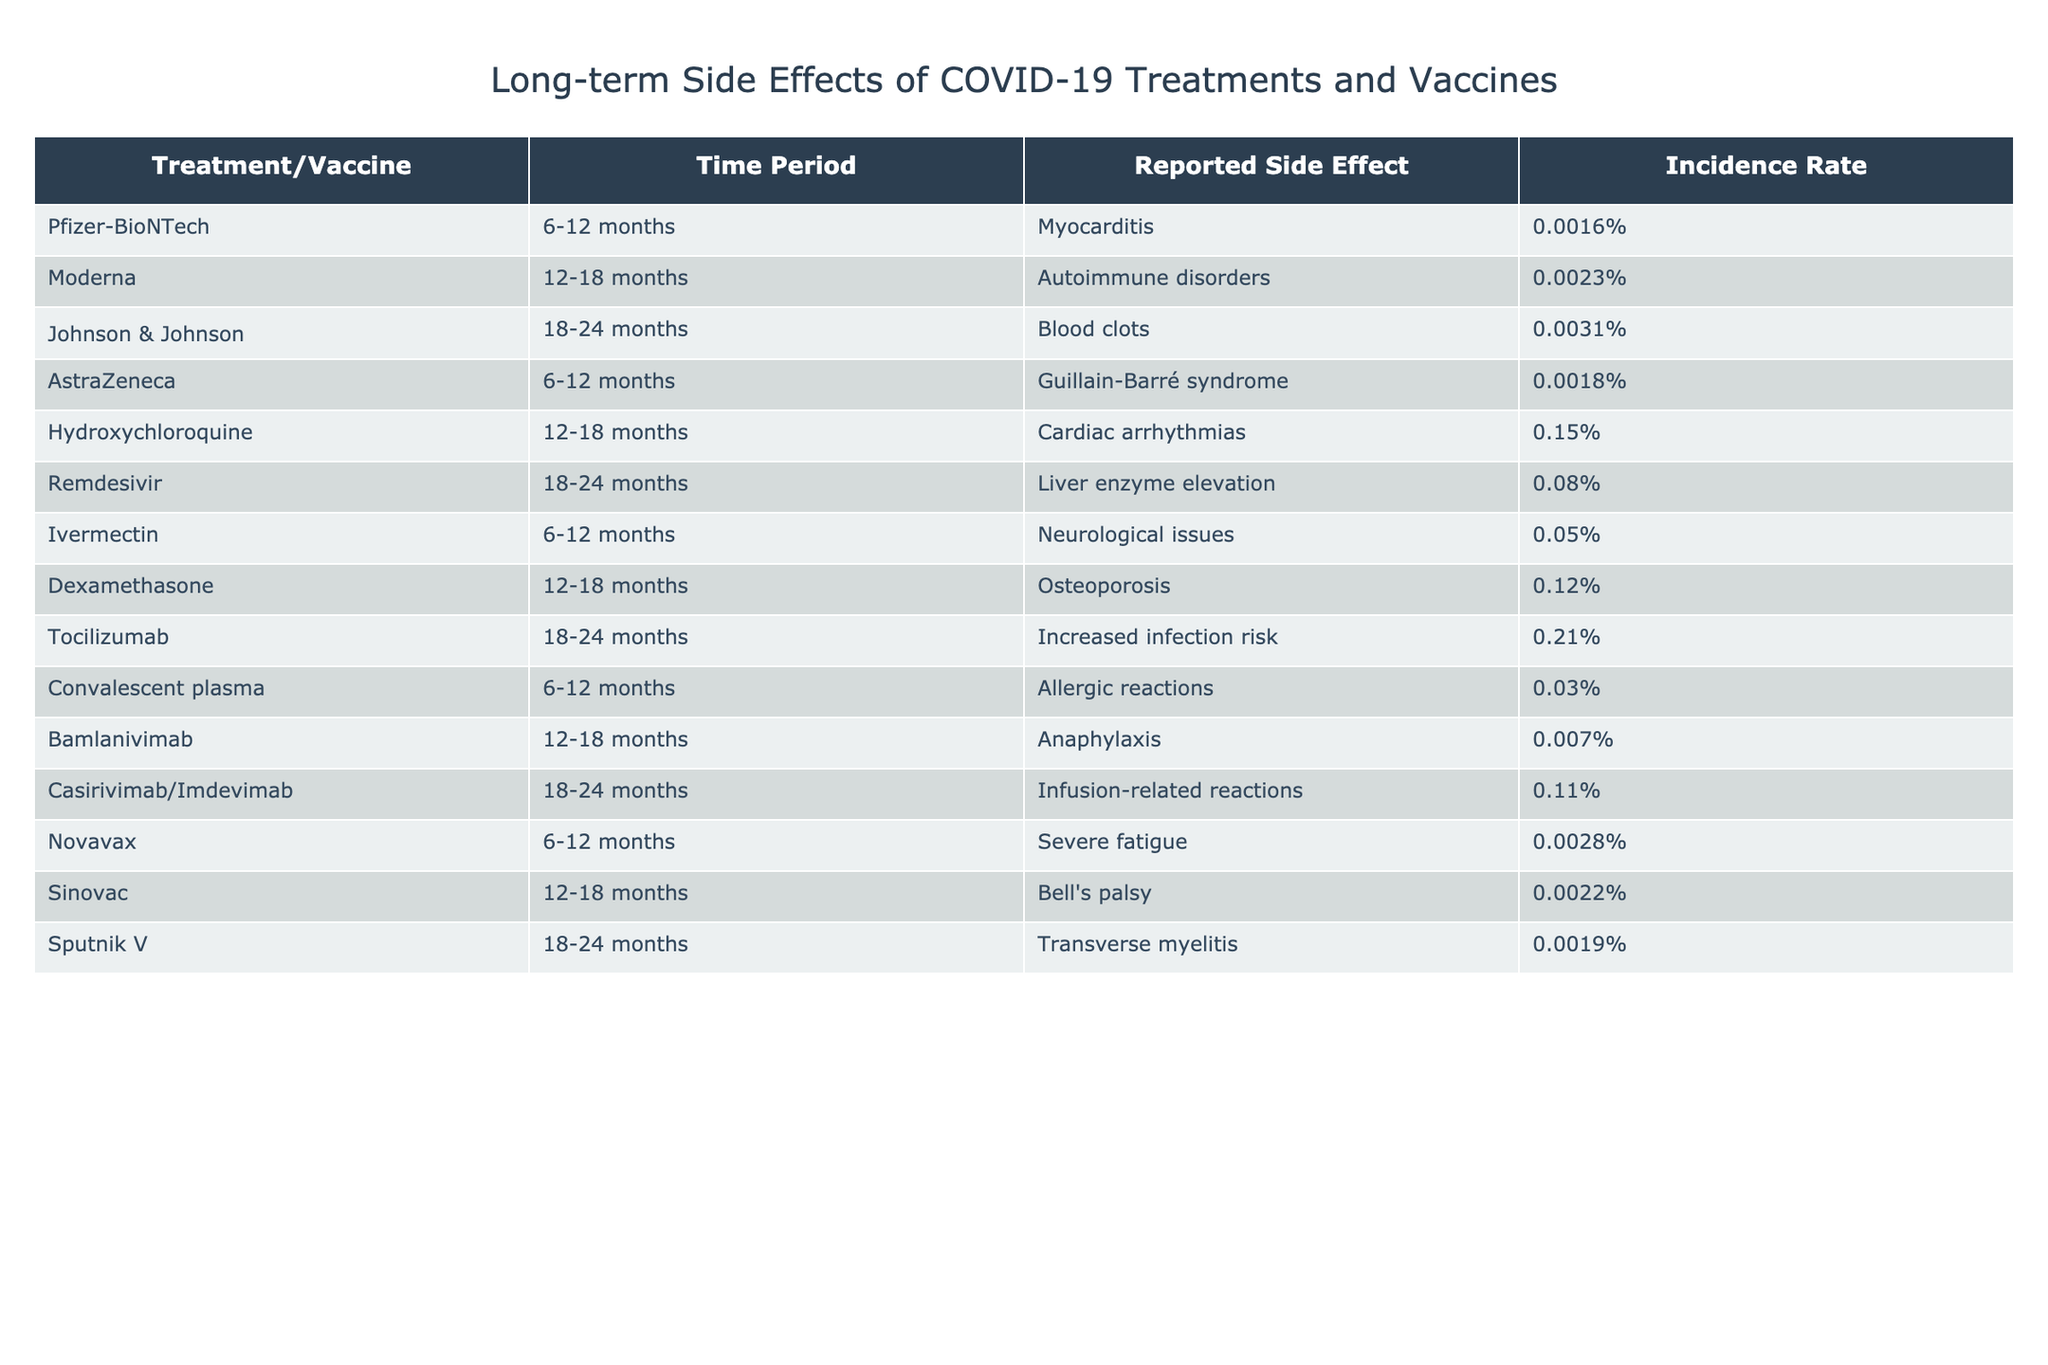What is the incidence rate of myocarditis after the Pfizer-BioNTech vaccine? The table shows that myocarditis is reported with an incidence rate of 0.0016% after the Pfizer-BioNTech vaccine.
Answer: 0.0016% Which treatment has the highest incidence rate for long-term side effects? In the table, hydroxychloroquine has the highest incidence rate for long-term side effects at 0.15%.
Answer: Hydroxychloroquine Is there a reported incidence of blood clots for the Johnson & Johnson vaccine? Yes, according to the table, blood clots are reported with an incidence rate of 0.0031% after the Johnson & Johnson vaccine.
Answer: Yes What is the average incidence rate of the reported side effects for all treatments and vaccines listed? By summing all the incidence rates: 0.0016 + 0.0023 + 0.0031 + 0.0018 + 0.15 + 0.08 + 0.05 + 0.12 + 0.21 + 0.03 + 0.007 + 0.11 + 0.0028 + 0.0022 + 0.0019 = 0.4, and there are 15 treatments, so, the average is 0.4/15 = 0.02667%.
Answer: 0.02667% Which side effect is associated with the AstraZeneca vaccine, and what is its incidence rate? The table states that the AstraZeneca vaccine is associated with Guillain-Barré syndrome, which has an incidence rate of 0.0018%.
Answer: Guillain-Barré syndrome, 0.0018% How many treatments or vaccines report an incidence rate higher than 0.1%? Looking through the table, the treatments that report an incidence higher than 0.1% are hydroxychloroquine (0.15%), remdesivir (0.08%), tocilizumab (0.21%), and dexamethasone (0.12%). Thus, 4 treatments have an incidence rate above 0.1%.
Answer: 4 What is the difference in incidence rates between the side effects of the Moderna vaccine and the Hydroxychloroquine treatment? The incidence rate for autoimmune disorders after the Moderna vaccine is 0.0023%, and for cardiac arrhythmias from hydroxychloroquine, it is 0.15%. The difference is calculated as 0.15% - 0.0023% = 0.1477%.
Answer: 0.1477% Does the incidence of severe fatigue from the Novavax vaccine exceed 0.002%? The table lists severe fatigue from the Novavax vaccine at an incidence rate of 0.0028%, which is greater than 0.002%.
Answer: Yes Which side effect reported for Ivermectin has a higher incidence rate when compared with the AstraZeneca vaccine? The incidence rate for neurological issues from Ivermectin is 0.05%, while for Guillain-Barré syndrome from AstraZeneca it is 0.0018%. Since 0.05% is greater than 0.0018%, the side effect for Ivermectin has a higher incidence rate.
Answer: Yes What is the total incidence rate for side effects reported after 12-18 months for all treatments? The relevant incidence rates to consider are: Autoimmune disorders (0.0023%), Cardiac arrhythmias (0.15%), Osteoporosis (0.12%), Anaphylaxis (0.007%), Bell's palsy (0.0022%). Summing these gives 0.0023 + 0.15 + 0.12 + 0.007 + 0.0022 = 0.2815%.
Answer: 0.2815% Is there any treatment that has the same incidence rate for long-term side effects as the Convalescent plasma? According to the table, the incidence rate for allergic reactions associated with Convalescent plasma is 0.03%. The table reveals that no other treatment shares this exact rate.
Answer: No 